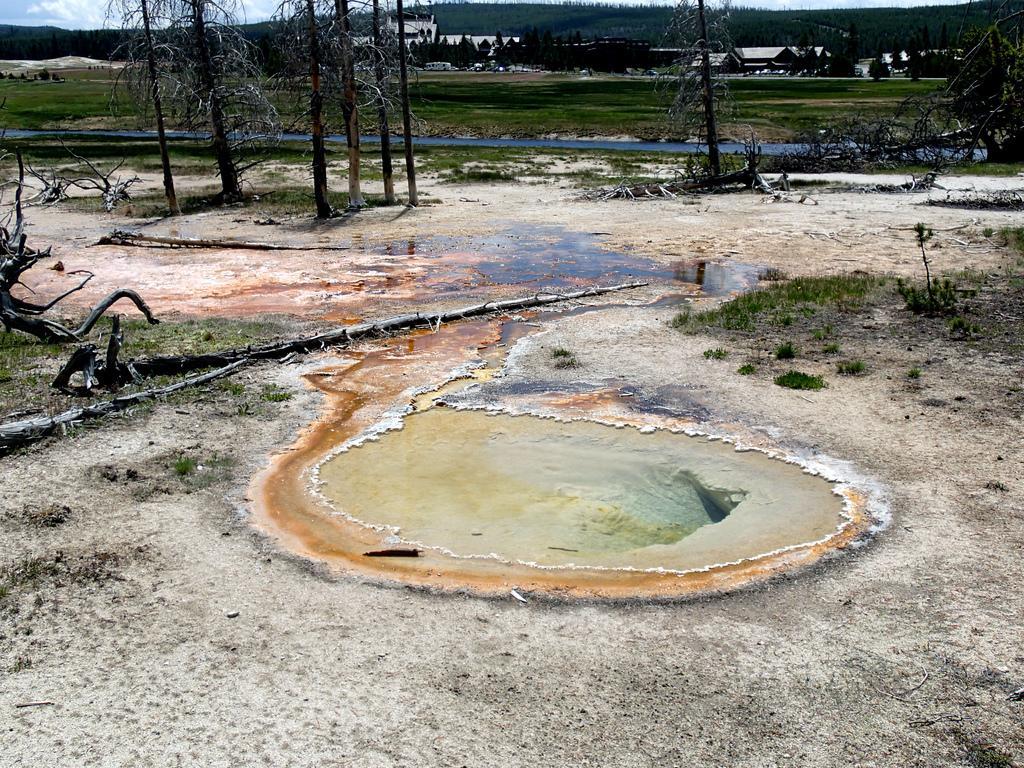Please provide a concise description of this image. In this image we can see pond, trees, grass, buildings, hills and sky with clouds. 